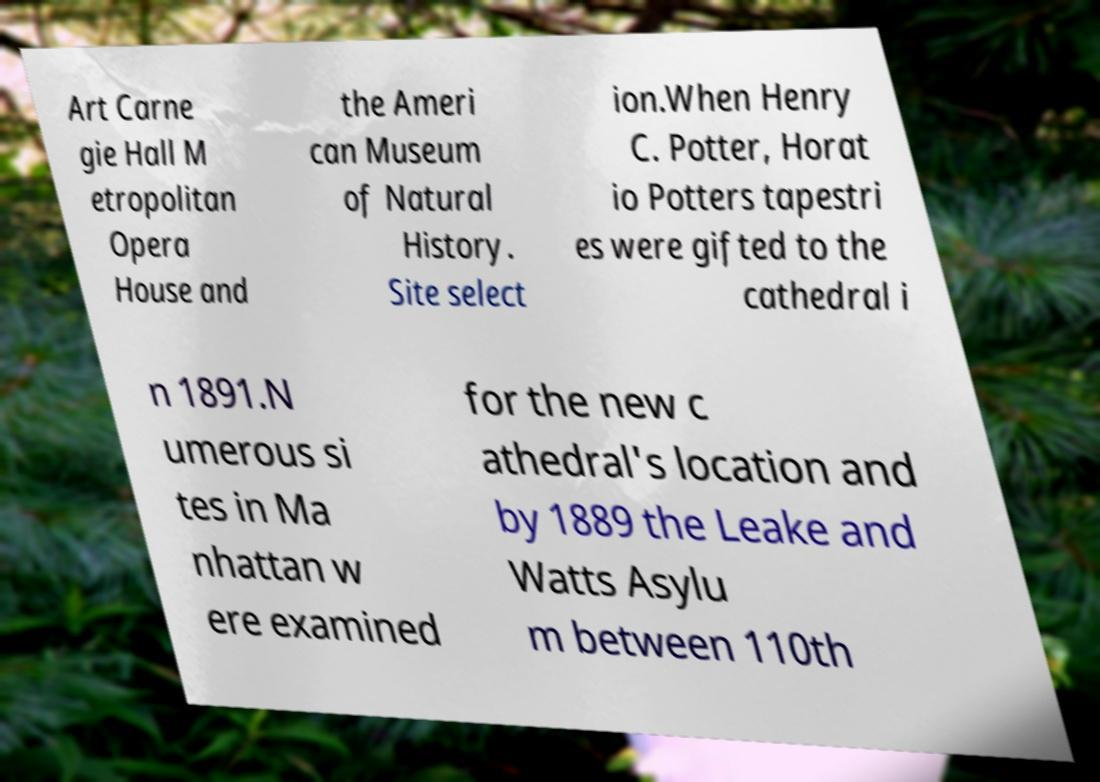Please identify and transcribe the text found in this image. Art Carne gie Hall M etropolitan Opera House and the Ameri can Museum of Natural History. Site select ion.When Henry C. Potter, Horat io Potters tapestri es were gifted to the cathedral i n 1891.N umerous si tes in Ma nhattan w ere examined for the new c athedral's location and by 1889 the Leake and Watts Asylu m between 110th 